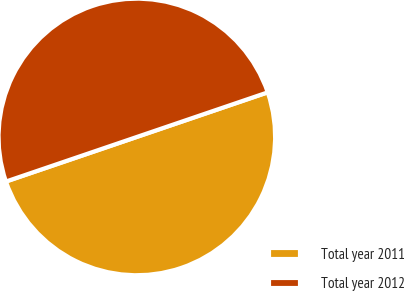Convert chart. <chart><loc_0><loc_0><loc_500><loc_500><pie_chart><fcel>Total year 2011<fcel>Total year 2012<nl><fcel>50.0%<fcel>50.0%<nl></chart> 